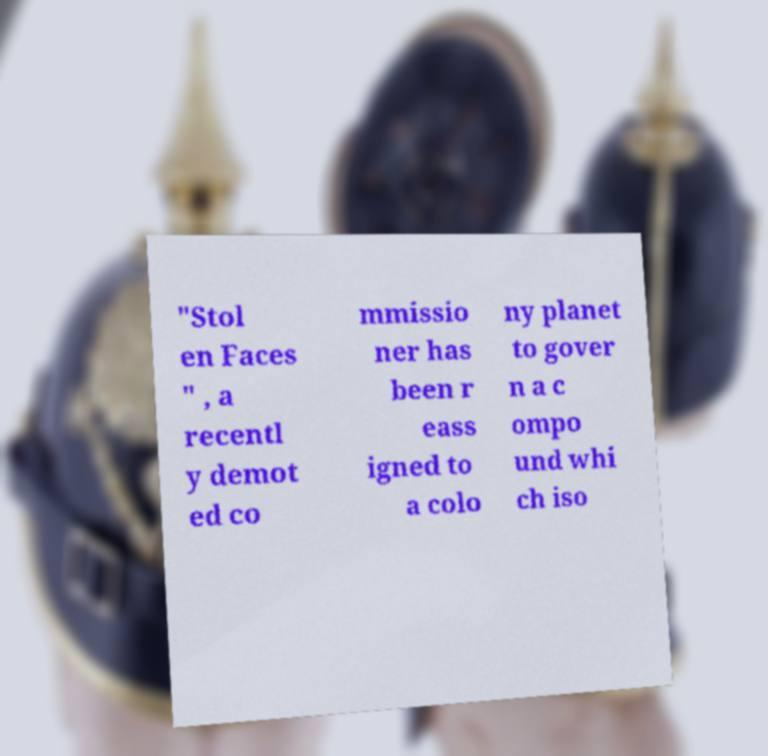Can you accurately transcribe the text from the provided image for me? "Stol en Faces " , a recentl y demot ed co mmissio ner has been r eass igned to a colo ny planet to gover n a c ompo und whi ch iso 